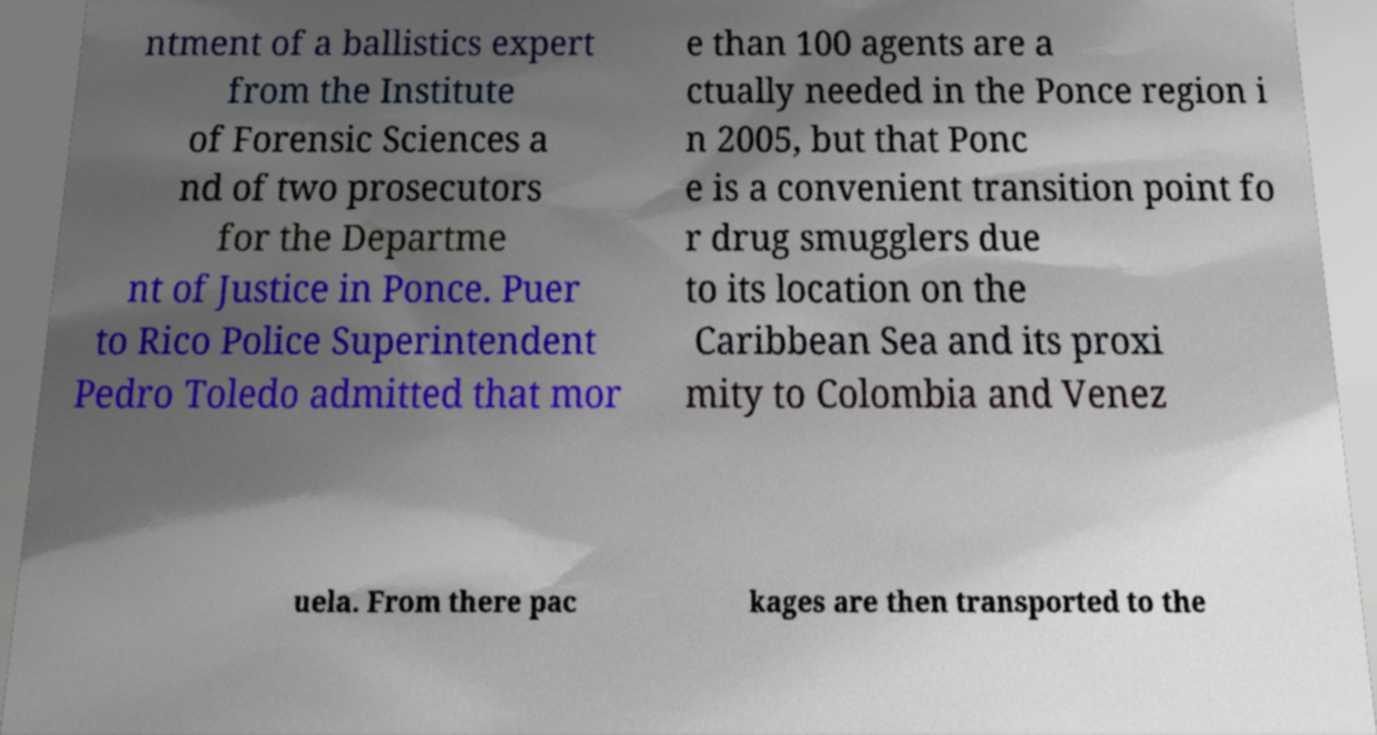Please identify and transcribe the text found in this image. ntment of a ballistics expert from the Institute of Forensic Sciences a nd of two prosecutors for the Departme nt of Justice in Ponce. Puer to Rico Police Superintendent Pedro Toledo admitted that mor e than 100 agents are a ctually needed in the Ponce region i n 2005, but that Ponc e is a convenient transition point fo r drug smugglers due to its location on the Caribbean Sea and its proxi mity to Colombia and Venez uela. From there pac kages are then transported to the 